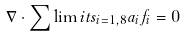<formula> <loc_0><loc_0><loc_500><loc_500>\nabla \cdot \sum \lim i t s _ { i = 1 , 8 } a _ { i } f _ { i } = 0</formula> 